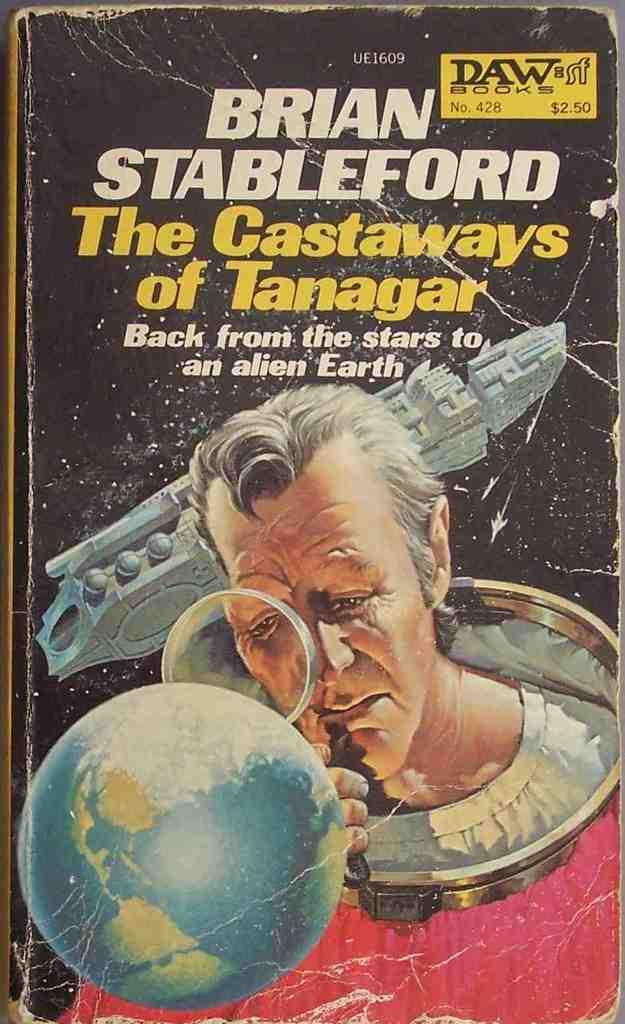<image>
Write a terse but informative summary of the picture. a Brian Stableford book that has a person's face on it 